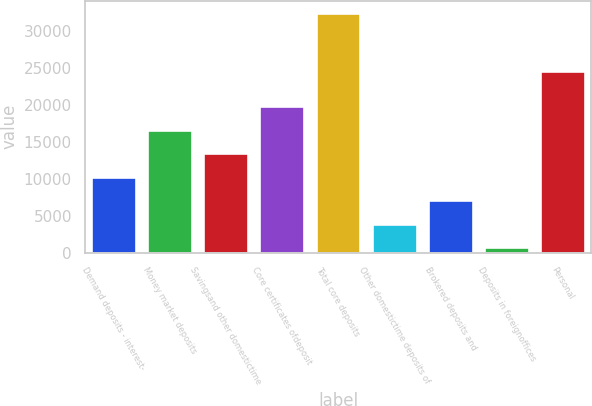Convert chart. <chart><loc_0><loc_0><loc_500><loc_500><bar_chart><fcel>Demand deposits - interest-<fcel>Money market deposits<fcel>Savingsand other domestictime<fcel>Core certificates ofdeposit<fcel>Total core deposits<fcel>Other domestictime deposits of<fcel>Brokered deposits and<fcel>Deposits in foreignoffices<fcel>Personal<nl><fcel>10271.5<fcel>16630.5<fcel>13451<fcel>19810<fcel>32528<fcel>3912.5<fcel>7092<fcel>733<fcel>24557<nl></chart> 